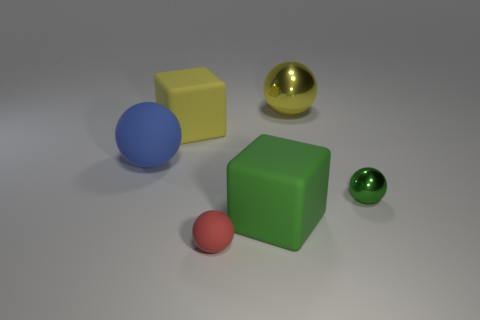Is there another object that has the same material as the blue object?
Your response must be concise. Yes. There is a matte object in front of the green rubber thing; what shape is it?
Give a very brief answer. Sphere. Does the big matte thing on the right side of the tiny red matte ball have the same color as the small metallic thing?
Your answer should be very brief. Yes. Is the number of green objects that are in front of the red rubber thing less than the number of small yellow things?
Provide a short and direct response. No. The large sphere that is the same material as the green block is what color?
Provide a succinct answer. Blue. There is a matte block behind the large blue matte sphere; what size is it?
Your answer should be very brief. Large. Is the green sphere made of the same material as the blue sphere?
Provide a short and direct response. No. There is a block left of the large rubber object that is on the right side of the yellow rubber block; are there any tiny matte things that are behind it?
Provide a short and direct response. No. What is the color of the small metal thing?
Keep it short and to the point. Green. There is a sphere that is the same size as the yellow metal object; what color is it?
Keep it short and to the point. Blue. 